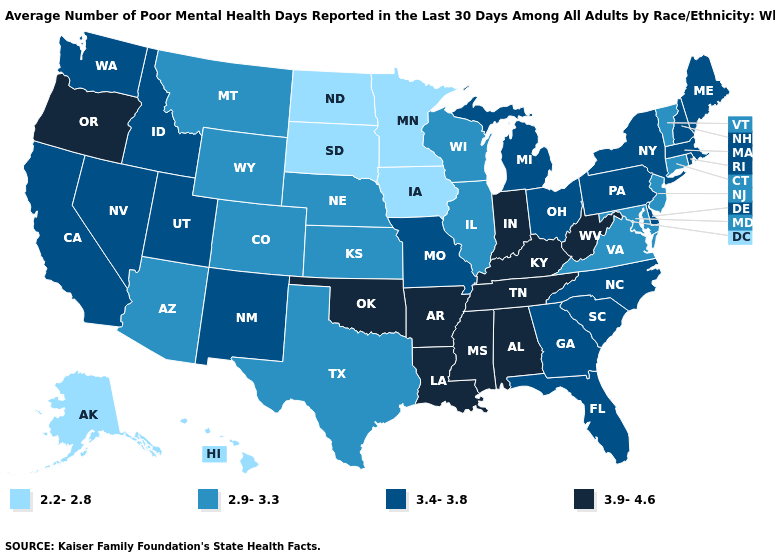Among the states that border Virginia , which have the lowest value?
Answer briefly. Maryland. Name the states that have a value in the range 3.4-3.8?
Concise answer only. California, Delaware, Florida, Georgia, Idaho, Maine, Massachusetts, Michigan, Missouri, Nevada, New Hampshire, New Mexico, New York, North Carolina, Ohio, Pennsylvania, Rhode Island, South Carolina, Utah, Washington. Name the states that have a value in the range 2.9-3.3?
Write a very short answer. Arizona, Colorado, Connecticut, Illinois, Kansas, Maryland, Montana, Nebraska, New Jersey, Texas, Vermont, Virginia, Wisconsin, Wyoming. Does Virginia have the same value as Iowa?
Write a very short answer. No. Name the states that have a value in the range 2.2-2.8?
Answer briefly. Alaska, Hawaii, Iowa, Minnesota, North Dakota, South Dakota. What is the value of Virginia?
Give a very brief answer. 2.9-3.3. What is the lowest value in states that border Mississippi?
Concise answer only. 3.9-4.6. Does West Virginia have the highest value in the USA?
Write a very short answer. Yes. What is the value of New York?
Keep it brief. 3.4-3.8. What is the value of Texas?
Concise answer only. 2.9-3.3. Name the states that have a value in the range 2.2-2.8?
Write a very short answer. Alaska, Hawaii, Iowa, Minnesota, North Dakota, South Dakota. Which states have the lowest value in the Northeast?
Keep it brief. Connecticut, New Jersey, Vermont. Does the map have missing data?
Quick response, please. No. Which states have the lowest value in the USA?
Answer briefly. Alaska, Hawaii, Iowa, Minnesota, North Dakota, South Dakota. Does Virginia have the highest value in the USA?
Quick response, please. No. 